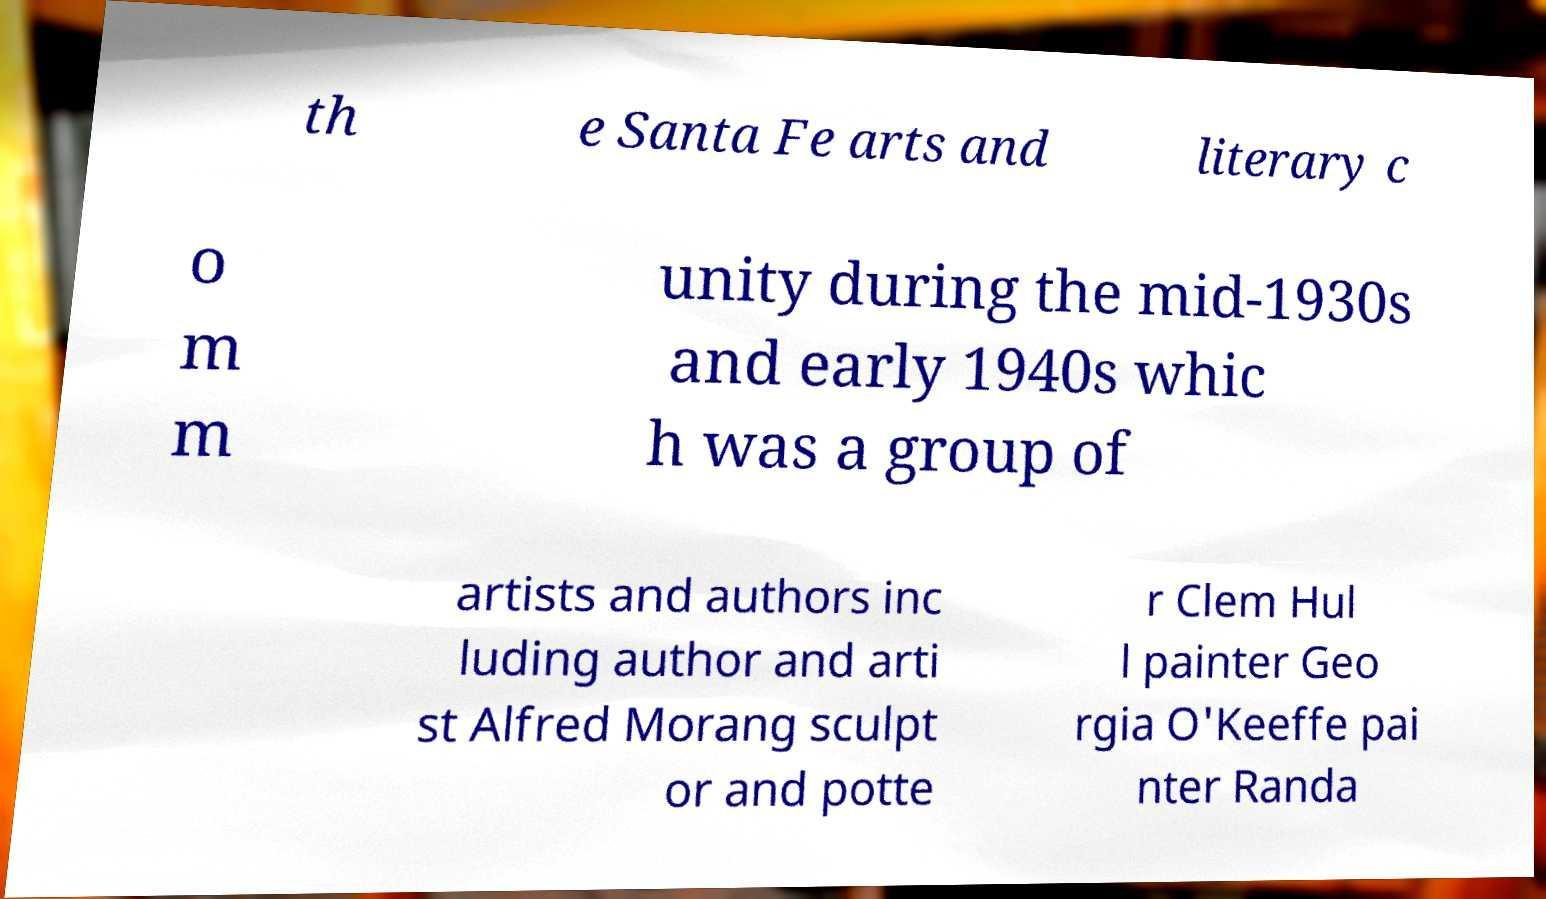I need the written content from this picture converted into text. Can you do that? th e Santa Fe arts and literary c o m m unity during the mid-1930s and early 1940s whic h was a group of artists and authors inc luding author and arti st Alfred Morang sculpt or and potte r Clem Hul l painter Geo rgia O'Keeffe pai nter Randa 